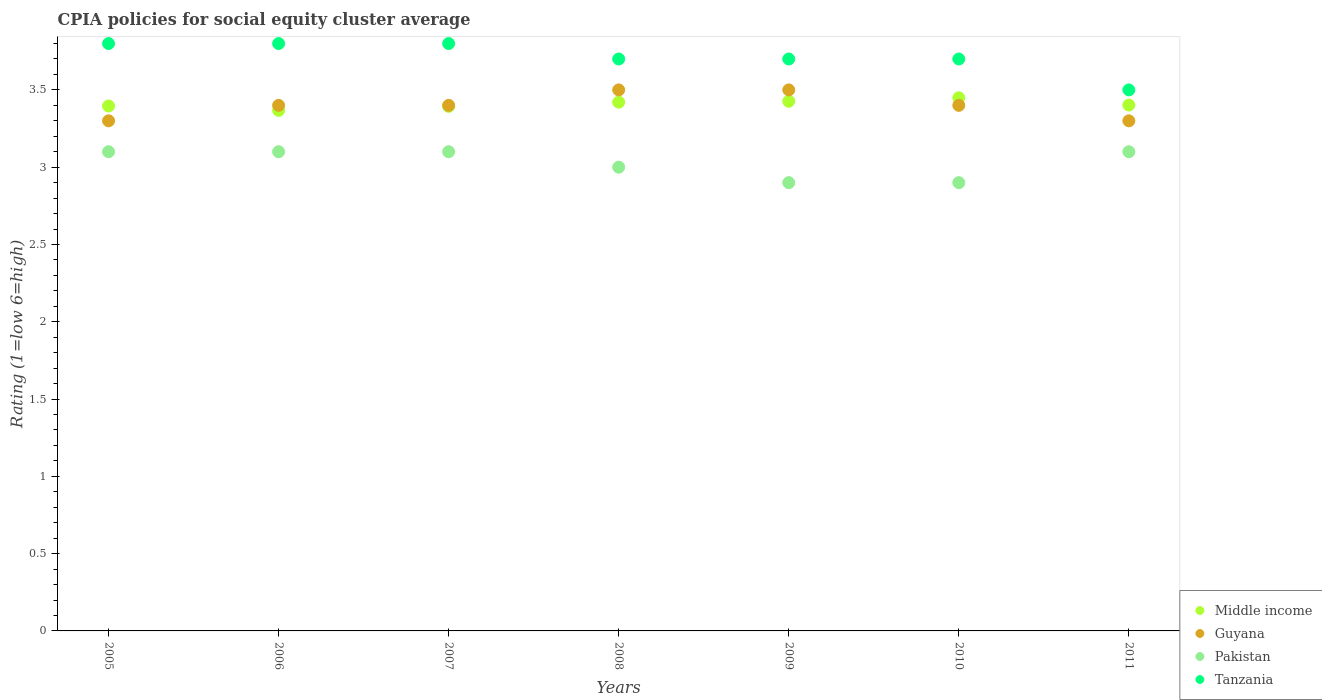Is the number of dotlines equal to the number of legend labels?
Give a very brief answer. Yes. Across all years, what is the maximum CPIA rating in Middle income?
Keep it short and to the point. 3.45. Across all years, what is the minimum CPIA rating in Pakistan?
Give a very brief answer. 2.9. What is the total CPIA rating in Guyana in the graph?
Keep it short and to the point. 23.8. What is the difference between the CPIA rating in Guyana in 2005 and that in 2006?
Offer a very short reply. -0.1. What is the difference between the CPIA rating in Pakistan in 2006 and the CPIA rating in Guyana in 2005?
Keep it short and to the point. -0.2. What is the average CPIA rating in Pakistan per year?
Offer a terse response. 3.03. In the year 2011, what is the difference between the CPIA rating in Guyana and CPIA rating in Tanzania?
Make the answer very short. -0.2. In how many years, is the CPIA rating in Guyana greater than 2.2?
Provide a succinct answer. 7. What is the ratio of the CPIA rating in Tanzania in 2007 to that in 2010?
Your response must be concise. 1.03. Is the difference between the CPIA rating in Guyana in 2006 and 2008 greater than the difference between the CPIA rating in Tanzania in 2006 and 2008?
Your answer should be compact. No. What is the difference between the highest and the lowest CPIA rating in Pakistan?
Your answer should be very brief. 0.2. In how many years, is the CPIA rating in Middle income greater than the average CPIA rating in Middle income taken over all years?
Give a very brief answer. 3. Is it the case that in every year, the sum of the CPIA rating in Pakistan and CPIA rating in Tanzania  is greater than the CPIA rating in Guyana?
Make the answer very short. Yes. Is the CPIA rating in Guyana strictly less than the CPIA rating in Middle income over the years?
Give a very brief answer. No. Are the values on the major ticks of Y-axis written in scientific E-notation?
Offer a very short reply. No. Does the graph contain any zero values?
Your response must be concise. No. How many legend labels are there?
Your answer should be very brief. 4. What is the title of the graph?
Your answer should be compact. CPIA policies for social equity cluster average. What is the label or title of the X-axis?
Make the answer very short. Years. What is the label or title of the Y-axis?
Make the answer very short. Rating (1=low 6=high). What is the Rating (1=low 6=high) of Middle income in 2005?
Ensure brevity in your answer.  3.4. What is the Rating (1=low 6=high) of Pakistan in 2005?
Offer a terse response. 3.1. What is the Rating (1=low 6=high) of Middle income in 2006?
Offer a very short reply. 3.37. What is the Rating (1=low 6=high) of Pakistan in 2006?
Offer a terse response. 3.1. What is the Rating (1=low 6=high) in Middle income in 2007?
Provide a succinct answer. 3.39. What is the Rating (1=low 6=high) of Guyana in 2007?
Your response must be concise. 3.4. What is the Rating (1=low 6=high) of Pakistan in 2007?
Provide a short and direct response. 3.1. What is the Rating (1=low 6=high) in Tanzania in 2007?
Ensure brevity in your answer.  3.8. What is the Rating (1=low 6=high) in Middle income in 2008?
Your answer should be very brief. 3.42. What is the Rating (1=low 6=high) in Middle income in 2009?
Your response must be concise. 3.43. What is the Rating (1=low 6=high) of Guyana in 2009?
Provide a short and direct response. 3.5. What is the Rating (1=low 6=high) in Middle income in 2010?
Your answer should be compact. 3.45. What is the Rating (1=low 6=high) in Pakistan in 2010?
Make the answer very short. 2.9. What is the Rating (1=low 6=high) of Tanzania in 2010?
Offer a very short reply. 3.7. What is the Rating (1=low 6=high) in Middle income in 2011?
Ensure brevity in your answer.  3.4. What is the Rating (1=low 6=high) of Pakistan in 2011?
Make the answer very short. 3.1. What is the Rating (1=low 6=high) of Tanzania in 2011?
Make the answer very short. 3.5. Across all years, what is the maximum Rating (1=low 6=high) in Middle income?
Your response must be concise. 3.45. Across all years, what is the maximum Rating (1=low 6=high) in Pakistan?
Make the answer very short. 3.1. Across all years, what is the maximum Rating (1=low 6=high) of Tanzania?
Provide a succinct answer. 3.8. Across all years, what is the minimum Rating (1=low 6=high) in Middle income?
Your answer should be very brief. 3.37. Across all years, what is the minimum Rating (1=low 6=high) of Tanzania?
Keep it short and to the point. 3.5. What is the total Rating (1=low 6=high) in Middle income in the graph?
Your response must be concise. 23.86. What is the total Rating (1=low 6=high) in Guyana in the graph?
Give a very brief answer. 23.8. What is the total Rating (1=low 6=high) of Pakistan in the graph?
Offer a terse response. 21.2. What is the total Rating (1=low 6=high) in Tanzania in the graph?
Keep it short and to the point. 26. What is the difference between the Rating (1=low 6=high) of Middle income in 2005 and that in 2006?
Your answer should be compact. 0.03. What is the difference between the Rating (1=low 6=high) of Guyana in 2005 and that in 2006?
Your answer should be very brief. -0.1. What is the difference between the Rating (1=low 6=high) in Middle income in 2005 and that in 2007?
Your answer should be compact. 0. What is the difference between the Rating (1=low 6=high) in Tanzania in 2005 and that in 2007?
Ensure brevity in your answer.  0. What is the difference between the Rating (1=low 6=high) of Middle income in 2005 and that in 2008?
Provide a short and direct response. -0.03. What is the difference between the Rating (1=low 6=high) in Guyana in 2005 and that in 2008?
Make the answer very short. -0.2. What is the difference between the Rating (1=low 6=high) in Tanzania in 2005 and that in 2008?
Offer a terse response. 0.1. What is the difference between the Rating (1=low 6=high) in Middle income in 2005 and that in 2009?
Offer a very short reply. -0.03. What is the difference between the Rating (1=low 6=high) in Guyana in 2005 and that in 2009?
Keep it short and to the point. -0.2. What is the difference between the Rating (1=low 6=high) in Tanzania in 2005 and that in 2009?
Your response must be concise. 0.1. What is the difference between the Rating (1=low 6=high) in Middle income in 2005 and that in 2010?
Offer a very short reply. -0.05. What is the difference between the Rating (1=low 6=high) in Guyana in 2005 and that in 2010?
Give a very brief answer. -0.1. What is the difference between the Rating (1=low 6=high) in Middle income in 2005 and that in 2011?
Provide a short and direct response. -0.01. What is the difference between the Rating (1=low 6=high) of Pakistan in 2005 and that in 2011?
Offer a terse response. 0. What is the difference between the Rating (1=low 6=high) in Tanzania in 2005 and that in 2011?
Your answer should be compact. 0.3. What is the difference between the Rating (1=low 6=high) in Middle income in 2006 and that in 2007?
Offer a terse response. -0.03. What is the difference between the Rating (1=low 6=high) in Tanzania in 2006 and that in 2007?
Make the answer very short. 0. What is the difference between the Rating (1=low 6=high) of Middle income in 2006 and that in 2008?
Your answer should be compact. -0.05. What is the difference between the Rating (1=low 6=high) of Pakistan in 2006 and that in 2008?
Your answer should be very brief. 0.1. What is the difference between the Rating (1=low 6=high) of Middle income in 2006 and that in 2009?
Ensure brevity in your answer.  -0.06. What is the difference between the Rating (1=low 6=high) in Tanzania in 2006 and that in 2009?
Provide a short and direct response. 0.1. What is the difference between the Rating (1=low 6=high) in Middle income in 2006 and that in 2010?
Make the answer very short. -0.08. What is the difference between the Rating (1=low 6=high) of Guyana in 2006 and that in 2010?
Your answer should be compact. 0. What is the difference between the Rating (1=low 6=high) in Pakistan in 2006 and that in 2010?
Offer a very short reply. 0.2. What is the difference between the Rating (1=low 6=high) of Middle income in 2006 and that in 2011?
Offer a terse response. -0.03. What is the difference between the Rating (1=low 6=high) in Middle income in 2007 and that in 2008?
Give a very brief answer. -0.03. What is the difference between the Rating (1=low 6=high) of Tanzania in 2007 and that in 2008?
Ensure brevity in your answer.  0.1. What is the difference between the Rating (1=low 6=high) in Middle income in 2007 and that in 2009?
Offer a very short reply. -0.03. What is the difference between the Rating (1=low 6=high) of Pakistan in 2007 and that in 2009?
Your answer should be very brief. 0.2. What is the difference between the Rating (1=low 6=high) in Tanzania in 2007 and that in 2009?
Provide a succinct answer. 0.1. What is the difference between the Rating (1=low 6=high) in Middle income in 2007 and that in 2010?
Provide a short and direct response. -0.06. What is the difference between the Rating (1=low 6=high) of Middle income in 2007 and that in 2011?
Provide a succinct answer. -0.01. What is the difference between the Rating (1=low 6=high) in Guyana in 2007 and that in 2011?
Keep it short and to the point. 0.1. What is the difference between the Rating (1=low 6=high) of Middle income in 2008 and that in 2009?
Make the answer very short. -0.01. What is the difference between the Rating (1=low 6=high) of Guyana in 2008 and that in 2009?
Your answer should be very brief. 0. What is the difference between the Rating (1=low 6=high) of Pakistan in 2008 and that in 2009?
Give a very brief answer. 0.1. What is the difference between the Rating (1=low 6=high) in Middle income in 2008 and that in 2010?
Provide a short and direct response. -0.03. What is the difference between the Rating (1=low 6=high) in Middle income in 2008 and that in 2011?
Provide a succinct answer. 0.02. What is the difference between the Rating (1=low 6=high) in Guyana in 2008 and that in 2011?
Offer a very short reply. 0.2. What is the difference between the Rating (1=low 6=high) of Middle income in 2009 and that in 2010?
Provide a succinct answer. -0.02. What is the difference between the Rating (1=low 6=high) of Middle income in 2009 and that in 2011?
Give a very brief answer. 0.02. What is the difference between the Rating (1=low 6=high) in Guyana in 2009 and that in 2011?
Give a very brief answer. 0.2. What is the difference between the Rating (1=low 6=high) in Tanzania in 2009 and that in 2011?
Keep it short and to the point. 0.2. What is the difference between the Rating (1=low 6=high) of Middle income in 2010 and that in 2011?
Offer a terse response. 0.05. What is the difference between the Rating (1=low 6=high) in Guyana in 2010 and that in 2011?
Keep it short and to the point. 0.1. What is the difference between the Rating (1=low 6=high) of Middle income in 2005 and the Rating (1=low 6=high) of Guyana in 2006?
Offer a terse response. -0. What is the difference between the Rating (1=low 6=high) of Middle income in 2005 and the Rating (1=low 6=high) of Pakistan in 2006?
Your answer should be compact. 0.3. What is the difference between the Rating (1=low 6=high) of Middle income in 2005 and the Rating (1=low 6=high) of Tanzania in 2006?
Keep it short and to the point. -0.4. What is the difference between the Rating (1=low 6=high) of Guyana in 2005 and the Rating (1=low 6=high) of Pakistan in 2006?
Keep it short and to the point. 0.2. What is the difference between the Rating (1=low 6=high) of Middle income in 2005 and the Rating (1=low 6=high) of Guyana in 2007?
Offer a very short reply. -0. What is the difference between the Rating (1=low 6=high) of Middle income in 2005 and the Rating (1=low 6=high) of Pakistan in 2007?
Provide a short and direct response. 0.3. What is the difference between the Rating (1=low 6=high) in Middle income in 2005 and the Rating (1=low 6=high) in Tanzania in 2007?
Provide a succinct answer. -0.4. What is the difference between the Rating (1=low 6=high) in Guyana in 2005 and the Rating (1=low 6=high) in Pakistan in 2007?
Offer a very short reply. 0.2. What is the difference between the Rating (1=low 6=high) of Pakistan in 2005 and the Rating (1=low 6=high) of Tanzania in 2007?
Offer a very short reply. -0.7. What is the difference between the Rating (1=low 6=high) in Middle income in 2005 and the Rating (1=low 6=high) in Guyana in 2008?
Make the answer very short. -0.1. What is the difference between the Rating (1=low 6=high) in Middle income in 2005 and the Rating (1=low 6=high) in Pakistan in 2008?
Ensure brevity in your answer.  0.4. What is the difference between the Rating (1=low 6=high) in Middle income in 2005 and the Rating (1=low 6=high) in Tanzania in 2008?
Ensure brevity in your answer.  -0.3. What is the difference between the Rating (1=low 6=high) in Middle income in 2005 and the Rating (1=low 6=high) in Guyana in 2009?
Provide a succinct answer. -0.1. What is the difference between the Rating (1=low 6=high) of Middle income in 2005 and the Rating (1=low 6=high) of Pakistan in 2009?
Provide a short and direct response. 0.5. What is the difference between the Rating (1=low 6=high) of Middle income in 2005 and the Rating (1=low 6=high) of Tanzania in 2009?
Your answer should be very brief. -0.3. What is the difference between the Rating (1=low 6=high) in Guyana in 2005 and the Rating (1=low 6=high) in Tanzania in 2009?
Provide a succinct answer. -0.4. What is the difference between the Rating (1=low 6=high) of Pakistan in 2005 and the Rating (1=low 6=high) of Tanzania in 2009?
Ensure brevity in your answer.  -0.6. What is the difference between the Rating (1=low 6=high) in Middle income in 2005 and the Rating (1=low 6=high) in Guyana in 2010?
Offer a very short reply. -0. What is the difference between the Rating (1=low 6=high) in Middle income in 2005 and the Rating (1=low 6=high) in Pakistan in 2010?
Ensure brevity in your answer.  0.5. What is the difference between the Rating (1=low 6=high) in Middle income in 2005 and the Rating (1=low 6=high) in Tanzania in 2010?
Provide a short and direct response. -0.3. What is the difference between the Rating (1=low 6=high) in Guyana in 2005 and the Rating (1=low 6=high) in Pakistan in 2010?
Give a very brief answer. 0.4. What is the difference between the Rating (1=low 6=high) of Guyana in 2005 and the Rating (1=low 6=high) of Tanzania in 2010?
Provide a short and direct response. -0.4. What is the difference between the Rating (1=low 6=high) in Pakistan in 2005 and the Rating (1=low 6=high) in Tanzania in 2010?
Your answer should be compact. -0.6. What is the difference between the Rating (1=low 6=high) in Middle income in 2005 and the Rating (1=low 6=high) in Guyana in 2011?
Give a very brief answer. 0.1. What is the difference between the Rating (1=low 6=high) of Middle income in 2005 and the Rating (1=low 6=high) of Pakistan in 2011?
Offer a very short reply. 0.3. What is the difference between the Rating (1=low 6=high) in Middle income in 2005 and the Rating (1=low 6=high) in Tanzania in 2011?
Give a very brief answer. -0.1. What is the difference between the Rating (1=low 6=high) of Guyana in 2005 and the Rating (1=low 6=high) of Tanzania in 2011?
Your answer should be very brief. -0.2. What is the difference between the Rating (1=low 6=high) in Middle income in 2006 and the Rating (1=low 6=high) in Guyana in 2007?
Your response must be concise. -0.03. What is the difference between the Rating (1=low 6=high) in Middle income in 2006 and the Rating (1=low 6=high) in Pakistan in 2007?
Make the answer very short. 0.27. What is the difference between the Rating (1=low 6=high) of Middle income in 2006 and the Rating (1=low 6=high) of Tanzania in 2007?
Make the answer very short. -0.43. What is the difference between the Rating (1=low 6=high) in Guyana in 2006 and the Rating (1=low 6=high) in Pakistan in 2007?
Give a very brief answer. 0.3. What is the difference between the Rating (1=low 6=high) in Middle income in 2006 and the Rating (1=low 6=high) in Guyana in 2008?
Give a very brief answer. -0.13. What is the difference between the Rating (1=low 6=high) of Middle income in 2006 and the Rating (1=low 6=high) of Pakistan in 2008?
Provide a succinct answer. 0.37. What is the difference between the Rating (1=low 6=high) in Middle income in 2006 and the Rating (1=low 6=high) in Tanzania in 2008?
Your answer should be compact. -0.33. What is the difference between the Rating (1=low 6=high) of Guyana in 2006 and the Rating (1=low 6=high) of Pakistan in 2008?
Your response must be concise. 0.4. What is the difference between the Rating (1=low 6=high) in Pakistan in 2006 and the Rating (1=low 6=high) in Tanzania in 2008?
Offer a terse response. -0.6. What is the difference between the Rating (1=low 6=high) of Middle income in 2006 and the Rating (1=low 6=high) of Guyana in 2009?
Your answer should be very brief. -0.13. What is the difference between the Rating (1=low 6=high) of Middle income in 2006 and the Rating (1=low 6=high) of Pakistan in 2009?
Your response must be concise. 0.47. What is the difference between the Rating (1=low 6=high) of Middle income in 2006 and the Rating (1=low 6=high) of Tanzania in 2009?
Provide a succinct answer. -0.33. What is the difference between the Rating (1=low 6=high) in Guyana in 2006 and the Rating (1=low 6=high) in Pakistan in 2009?
Keep it short and to the point. 0.5. What is the difference between the Rating (1=low 6=high) in Pakistan in 2006 and the Rating (1=low 6=high) in Tanzania in 2009?
Keep it short and to the point. -0.6. What is the difference between the Rating (1=low 6=high) in Middle income in 2006 and the Rating (1=low 6=high) in Guyana in 2010?
Make the answer very short. -0.03. What is the difference between the Rating (1=low 6=high) in Middle income in 2006 and the Rating (1=low 6=high) in Pakistan in 2010?
Your answer should be very brief. 0.47. What is the difference between the Rating (1=low 6=high) of Middle income in 2006 and the Rating (1=low 6=high) of Tanzania in 2010?
Your answer should be compact. -0.33. What is the difference between the Rating (1=low 6=high) in Guyana in 2006 and the Rating (1=low 6=high) in Pakistan in 2010?
Ensure brevity in your answer.  0.5. What is the difference between the Rating (1=low 6=high) in Pakistan in 2006 and the Rating (1=low 6=high) in Tanzania in 2010?
Your answer should be compact. -0.6. What is the difference between the Rating (1=low 6=high) in Middle income in 2006 and the Rating (1=low 6=high) in Guyana in 2011?
Your answer should be very brief. 0.07. What is the difference between the Rating (1=low 6=high) of Middle income in 2006 and the Rating (1=low 6=high) of Pakistan in 2011?
Provide a short and direct response. 0.27. What is the difference between the Rating (1=low 6=high) of Middle income in 2006 and the Rating (1=low 6=high) of Tanzania in 2011?
Offer a terse response. -0.13. What is the difference between the Rating (1=low 6=high) of Guyana in 2006 and the Rating (1=low 6=high) of Pakistan in 2011?
Provide a short and direct response. 0.3. What is the difference between the Rating (1=low 6=high) in Pakistan in 2006 and the Rating (1=low 6=high) in Tanzania in 2011?
Make the answer very short. -0.4. What is the difference between the Rating (1=low 6=high) of Middle income in 2007 and the Rating (1=low 6=high) of Guyana in 2008?
Make the answer very short. -0.11. What is the difference between the Rating (1=low 6=high) in Middle income in 2007 and the Rating (1=low 6=high) in Pakistan in 2008?
Provide a succinct answer. 0.39. What is the difference between the Rating (1=low 6=high) in Middle income in 2007 and the Rating (1=low 6=high) in Tanzania in 2008?
Offer a terse response. -0.31. What is the difference between the Rating (1=low 6=high) in Middle income in 2007 and the Rating (1=low 6=high) in Guyana in 2009?
Offer a very short reply. -0.11. What is the difference between the Rating (1=low 6=high) of Middle income in 2007 and the Rating (1=low 6=high) of Pakistan in 2009?
Give a very brief answer. 0.49. What is the difference between the Rating (1=low 6=high) in Middle income in 2007 and the Rating (1=low 6=high) in Tanzania in 2009?
Give a very brief answer. -0.31. What is the difference between the Rating (1=low 6=high) in Guyana in 2007 and the Rating (1=low 6=high) in Tanzania in 2009?
Your answer should be compact. -0.3. What is the difference between the Rating (1=low 6=high) in Pakistan in 2007 and the Rating (1=low 6=high) in Tanzania in 2009?
Offer a very short reply. -0.6. What is the difference between the Rating (1=low 6=high) in Middle income in 2007 and the Rating (1=low 6=high) in Guyana in 2010?
Your answer should be compact. -0.01. What is the difference between the Rating (1=low 6=high) of Middle income in 2007 and the Rating (1=low 6=high) of Pakistan in 2010?
Offer a terse response. 0.49. What is the difference between the Rating (1=low 6=high) in Middle income in 2007 and the Rating (1=low 6=high) in Tanzania in 2010?
Keep it short and to the point. -0.31. What is the difference between the Rating (1=low 6=high) of Guyana in 2007 and the Rating (1=low 6=high) of Pakistan in 2010?
Offer a terse response. 0.5. What is the difference between the Rating (1=low 6=high) in Guyana in 2007 and the Rating (1=low 6=high) in Tanzania in 2010?
Offer a very short reply. -0.3. What is the difference between the Rating (1=low 6=high) of Pakistan in 2007 and the Rating (1=low 6=high) of Tanzania in 2010?
Your answer should be very brief. -0.6. What is the difference between the Rating (1=low 6=high) in Middle income in 2007 and the Rating (1=low 6=high) in Guyana in 2011?
Ensure brevity in your answer.  0.09. What is the difference between the Rating (1=low 6=high) in Middle income in 2007 and the Rating (1=low 6=high) in Pakistan in 2011?
Offer a very short reply. 0.29. What is the difference between the Rating (1=low 6=high) in Middle income in 2007 and the Rating (1=low 6=high) in Tanzania in 2011?
Offer a very short reply. -0.11. What is the difference between the Rating (1=low 6=high) in Guyana in 2007 and the Rating (1=low 6=high) in Tanzania in 2011?
Your response must be concise. -0.1. What is the difference between the Rating (1=low 6=high) in Middle income in 2008 and the Rating (1=low 6=high) in Guyana in 2009?
Your answer should be very brief. -0.08. What is the difference between the Rating (1=low 6=high) in Middle income in 2008 and the Rating (1=low 6=high) in Pakistan in 2009?
Provide a succinct answer. 0.52. What is the difference between the Rating (1=low 6=high) in Middle income in 2008 and the Rating (1=low 6=high) in Tanzania in 2009?
Offer a terse response. -0.28. What is the difference between the Rating (1=low 6=high) of Middle income in 2008 and the Rating (1=low 6=high) of Guyana in 2010?
Offer a very short reply. 0.02. What is the difference between the Rating (1=low 6=high) of Middle income in 2008 and the Rating (1=low 6=high) of Pakistan in 2010?
Offer a terse response. 0.52. What is the difference between the Rating (1=low 6=high) of Middle income in 2008 and the Rating (1=low 6=high) of Tanzania in 2010?
Offer a terse response. -0.28. What is the difference between the Rating (1=low 6=high) of Middle income in 2008 and the Rating (1=low 6=high) of Guyana in 2011?
Ensure brevity in your answer.  0.12. What is the difference between the Rating (1=low 6=high) in Middle income in 2008 and the Rating (1=low 6=high) in Pakistan in 2011?
Your answer should be compact. 0.32. What is the difference between the Rating (1=low 6=high) of Middle income in 2008 and the Rating (1=low 6=high) of Tanzania in 2011?
Provide a short and direct response. -0.08. What is the difference between the Rating (1=low 6=high) of Middle income in 2009 and the Rating (1=low 6=high) of Guyana in 2010?
Your answer should be very brief. 0.03. What is the difference between the Rating (1=low 6=high) of Middle income in 2009 and the Rating (1=low 6=high) of Pakistan in 2010?
Give a very brief answer. 0.53. What is the difference between the Rating (1=low 6=high) in Middle income in 2009 and the Rating (1=low 6=high) in Tanzania in 2010?
Ensure brevity in your answer.  -0.27. What is the difference between the Rating (1=low 6=high) of Guyana in 2009 and the Rating (1=low 6=high) of Pakistan in 2010?
Your answer should be very brief. 0.6. What is the difference between the Rating (1=low 6=high) in Guyana in 2009 and the Rating (1=low 6=high) in Tanzania in 2010?
Offer a very short reply. -0.2. What is the difference between the Rating (1=low 6=high) of Middle income in 2009 and the Rating (1=low 6=high) of Guyana in 2011?
Offer a terse response. 0.13. What is the difference between the Rating (1=low 6=high) in Middle income in 2009 and the Rating (1=low 6=high) in Pakistan in 2011?
Your answer should be compact. 0.33. What is the difference between the Rating (1=low 6=high) in Middle income in 2009 and the Rating (1=low 6=high) in Tanzania in 2011?
Your answer should be compact. -0.07. What is the difference between the Rating (1=low 6=high) of Guyana in 2009 and the Rating (1=low 6=high) of Pakistan in 2011?
Your answer should be compact. 0.4. What is the difference between the Rating (1=low 6=high) in Pakistan in 2009 and the Rating (1=low 6=high) in Tanzania in 2011?
Offer a terse response. -0.6. What is the difference between the Rating (1=low 6=high) of Middle income in 2010 and the Rating (1=low 6=high) of Guyana in 2011?
Give a very brief answer. 0.15. What is the difference between the Rating (1=low 6=high) in Middle income in 2010 and the Rating (1=low 6=high) in Pakistan in 2011?
Your response must be concise. 0.35. What is the difference between the Rating (1=low 6=high) of Middle income in 2010 and the Rating (1=low 6=high) of Tanzania in 2011?
Make the answer very short. -0.05. What is the difference between the Rating (1=low 6=high) of Guyana in 2010 and the Rating (1=low 6=high) of Pakistan in 2011?
Make the answer very short. 0.3. What is the difference between the Rating (1=low 6=high) of Guyana in 2010 and the Rating (1=low 6=high) of Tanzania in 2011?
Make the answer very short. -0.1. What is the difference between the Rating (1=low 6=high) in Pakistan in 2010 and the Rating (1=low 6=high) in Tanzania in 2011?
Your response must be concise. -0.6. What is the average Rating (1=low 6=high) in Middle income per year?
Offer a terse response. 3.41. What is the average Rating (1=low 6=high) in Pakistan per year?
Give a very brief answer. 3.03. What is the average Rating (1=low 6=high) in Tanzania per year?
Ensure brevity in your answer.  3.71. In the year 2005, what is the difference between the Rating (1=low 6=high) of Middle income and Rating (1=low 6=high) of Guyana?
Keep it short and to the point. 0.1. In the year 2005, what is the difference between the Rating (1=low 6=high) of Middle income and Rating (1=low 6=high) of Pakistan?
Provide a succinct answer. 0.3. In the year 2005, what is the difference between the Rating (1=low 6=high) of Middle income and Rating (1=low 6=high) of Tanzania?
Make the answer very short. -0.4. In the year 2005, what is the difference between the Rating (1=low 6=high) in Guyana and Rating (1=low 6=high) in Pakistan?
Your response must be concise. 0.2. In the year 2005, what is the difference between the Rating (1=low 6=high) in Pakistan and Rating (1=low 6=high) in Tanzania?
Make the answer very short. -0.7. In the year 2006, what is the difference between the Rating (1=low 6=high) in Middle income and Rating (1=low 6=high) in Guyana?
Offer a terse response. -0.03. In the year 2006, what is the difference between the Rating (1=low 6=high) of Middle income and Rating (1=low 6=high) of Pakistan?
Make the answer very short. 0.27. In the year 2006, what is the difference between the Rating (1=low 6=high) in Middle income and Rating (1=low 6=high) in Tanzania?
Your answer should be compact. -0.43. In the year 2007, what is the difference between the Rating (1=low 6=high) of Middle income and Rating (1=low 6=high) of Guyana?
Your response must be concise. -0.01. In the year 2007, what is the difference between the Rating (1=low 6=high) in Middle income and Rating (1=low 6=high) in Pakistan?
Keep it short and to the point. 0.29. In the year 2007, what is the difference between the Rating (1=low 6=high) of Middle income and Rating (1=low 6=high) of Tanzania?
Ensure brevity in your answer.  -0.41. In the year 2007, what is the difference between the Rating (1=low 6=high) of Guyana and Rating (1=low 6=high) of Pakistan?
Provide a succinct answer. 0.3. In the year 2007, what is the difference between the Rating (1=low 6=high) in Guyana and Rating (1=low 6=high) in Tanzania?
Keep it short and to the point. -0.4. In the year 2008, what is the difference between the Rating (1=low 6=high) of Middle income and Rating (1=low 6=high) of Guyana?
Your response must be concise. -0.08. In the year 2008, what is the difference between the Rating (1=low 6=high) in Middle income and Rating (1=low 6=high) in Pakistan?
Your answer should be compact. 0.42. In the year 2008, what is the difference between the Rating (1=low 6=high) of Middle income and Rating (1=low 6=high) of Tanzania?
Keep it short and to the point. -0.28. In the year 2008, what is the difference between the Rating (1=low 6=high) of Guyana and Rating (1=low 6=high) of Pakistan?
Your response must be concise. 0.5. In the year 2009, what is the difference between the Rating (1=low 6=high) of Middle income and Rating (1=low 6=high) of Guyana?
Provide a succinct answer. -0.07. In the year 2009, what is the difference between the Rating (1=low 6=high) in Middle income and Rating (1=low 6=high) in Pakistan?
Keep it short and to the point. 0.53. In the year 2009, what is the difference between the Rating (1=low 6=high) of Middle income and Rating (1=low 6=high) of Tanzania?
Your answer should be very brief. -0.27. In the year 2009, what is the difference between the Rating (1=low 6=high) in Guyana and Rating (1=low 6=high) in Pakistan?
Your answer should be very brief. 0.6. In the year 2009, what is the difference between the Rating (1=low 6=high) in Guyana and Rating (1=low 6=high) in Tanzania?
Offer a terse response. -0.2. In the year 2010, what is the difference between the Rating (1=low 6=high) in Middle income and Rating (1=low 6=high) in Guyana?
Your response must be concise. 0.05. In the year 2010, what is the difference between the Rating (1=low 6=high) in Middle income and Rating (1=low 6=high) in Pakistan?
Give a very brief answer. 0.55. In the year 2010, what is the difference between the Rating (1=low 6=high) of Middle income and Rating (1=low 6=high) of Tanzania?
Your answer should be very brief. -0.25. In the year 2010, what is the difference between the Rating (1=low 6=high) of Guyana and Rating (1=low 6=high) of Tanzania?
Provide a short and direct response. -0.3. In the year 2010, what is the difference between the Rating (1=low 6=high) in Pakistan and Rating (1=low 6=high) in Tanzania?
Provide a short and direct response. -0.8. In the year 2011, what is the difference between the Rating (1=low 6=high) of Middle income and Rating (1=low 6=high) of Guyana?
Your response must be concise. 0.1. In the year 2011, what is the difference between the Rating (1=low 6=high) of Middle income and Rating (1=low 6=high) of Pakistan?
Your answer should be very brief. 0.3. In the year 2011, what is the difference between the Rating (1=low 6=high) of Middle income and Rating (1=low 6=high) of Tanzania?
Give a very brief answer. -0.1. In the year 2011, what is the difference between the Rating (1=low 6=high) of Guyana and Rating (1=low 6=high) of Pakistan?
Offer a very short reply. 0.2. In the year 2011, what is the difference between the Rating (1=low 6=high) of Pakistan and Rating (1=low 6=high) of Tanzania?
Your answer should be compact. -0.4. What is the ratio of the Rating (1=low 6=high) of Middle income in 2005 to that in 2006?
Make the answer very short. 1.01. What is the ratio of the Rating (1=low 6=high) in Guyana in 2005 to that in 2006?
Keep it short and to the point. 0.97. What is the ratio of the Rating (1=low 6=high) in Pakistan in 2005 to that in 2006?
Offer a very short reply. 1. What is the ratio of the Rating (1=low 6=high) of Guyana in 2005 to that in 2007?
Offer a very short reply. 0.97. What is the ratio of the Rating (1=low 6=high) of Guyana in 2005 to that in 2008?
Offer a very short reply. 0.94. What is the ratio of the Rating (1=low 6=high) of Guyana in 2005 to that in 2009?
Your answer should be very brief. 0.94. What is the ratio of the Rating (1=low 6=high) of Pakistan in 2005 to that in 2009?
Your answer should be very brief. 1.07. What is the ratio of the Rating (1=low 6=high) of Tanzania in 2005 to that in 2009?
Your answer should be very brief. 1.03. What is the ratio of the Rating (1=low 6=high) in Middle income in 2005 to that in 2010?
Give a very brief answer. 0.98. What is the ratio of the Rating (1=low 6=high) of Guyana in 2005 to that in 2010?
Your answer should be very brief. 0.97. What is the ratio of the Rating (1=low 6=high) in Pakistan in 2005 to that in 2010?
Give a very brief answer. 1.07. What is the ratio of the Rating (1=low 6=high) in Tanzania in 2005 to that in 2010?
Keep it short and to the point. 1.03. What is the ratio of the Rating (1=low 6=high) in Middle income in 2005 to that in 2011?
Keep it short and to the point. 1. What is the ratio of the Rating (1=low 6=high) in Guyana in 2005 to that in 2011?
Offer a very short reply. 1. What is the ratio of the Rating (1=low 6=high) of Tanzania in 2005 to that in 2011?
Make the answer very short. 1.09. What is the ratio of the Rating (1=low 6=high) of Middle income in 2006 to that in 2007?
Make the answer very short. 0.99. What is the ratio of the Rating (1=low 6=high) of Tanzania in 2006 to that in 2007?
Your response must be concise. 1. What is the ratio of the Rating (1=low 6=high) of Middle income in 2006 to that in 2008?
Ensure brevity in your answer.  0.98. What is the ratio of the Rating (1=low 6=high) in Guyana in 2006 to that in 2008?
Keep it short and to the point. 0.97. What is the ratio of the Rating (1=low 6=high) of Pakistan in 2006 to that in 2008?
Your answer should be compact. 1.03. What is the ratio of the Rating (1=low 6=high) of Middle income in 2006 to that in 2009?
Your answer should be compact. 0.98. What is the ratio of the Rating (1=low 6=high) of Guyana in 2006 to that in 2009?
Give a very brief answer. 0.97. What is the ratio of the Rating (1=low 6=high) of Pakistan in 2006 to that in 2009?
Offer a very short reply. 1.07. What is the ratio of the Rating (1=low 6=high) of Tanzania in 2006 to that in 2009?
Offer a very short reply. 1.03. What is the ratio of the Rating (1=low 6=high) of Middle income in 2006 to that in 2010?
Your response must be concise. 0.98. What is the ratio of the Rating (1=low 6=high) of Guyana in 2006 to that in 2010?
Provide a short and direct response. 1. What is the ratio of the Rating (1=low 6=high) of Pakistan in 2006 to that in 2010?
Your answer should be compact. 1.07. What is the ratio of the Rating (1=low 6=high) in Tanzania in 2006 to that in 2010?
Your answer should be very brief. 1.03. What is the ratio of the Rating (1=low 6=high) in Middle income in 2006 to that in 2011?
Provide a succinct answer. 0.99. What is the ratio of the Rating (1=low 6=high) in Guyana in 2006 to that in 2011?
Make the answer very short. 1.03. What is the ratio of the Rating (1=low 6=high) of Pakistan in 2006 to that in 2011?
Your answer should be very brief. 1. What is the ratio of the Rating (1=low 6=high) in Tanzania in 2006 to that in 2011?
Keep it short and to the point. 1.09. What is the ratio of the Rating (1=low 6=high) of Guyana in 2007 to that in 2008?
Make the answer very short. 0.97. What is the ratio of the Rating (1=low 6=high) in Tanzania in 2007 to that in 2008?
Give a very brief answer. 1.03. What is the ratio of the Rating (1=low 6=high) in Guyana in 2007 to that in 2009?
Give a very brief answer. 0.97. What is the ratio of the Rating (1=low 6=high) of Pakistan in 2007 to that in 2009?
Your answer should be very brief. 1.07. What is the ratio of the Rating (1=low 6=high) in Middle income in 2007 to that in 2010?
Offer a very short reply. 0.98. What is the ratio of the Rating (1=low 6=high) in Pakistan in 2007 to that in 2010?
Provide a short and direct response. 1.07. What is the ratio of the Rating (1=low 6=high) in Tanzania in 2007 to that in 2010?
Offer a very short reply. 1.03. What is the ratio of the Rating (1=low 6=high) in Middle income in 2007 to that in 2011?
Offer a terse response. 1. What is the ratio of the Rating (1=low 6=high) of Guyana in 2007 to that in 2011?
Offer a very short reply. 1.03. What is the ratio of the Rating (1=low 6=high) of Pakistan in 2007 to that in 2011?
Provide a short and direct response. 1. What is the ratio of the Rating (1=low 6=high) in Tanzania in 2007 to that in 2011?
Your answer should be compact. 1.09. What is the ratio of the Rating (1=low 6=high) of Guyana in 2008 to that in 2009?
Provide a succinct answer. 1. What is the ratio of the Rating (1=low 6=high) of Pakistan in 2008 to that in 2009?
Offer a terse response. 1.03. What is the ratio of the Rating (1=low 6=high) of Guyana in 2008 to that in 2010?
Your answer should be very brief. 1.03. What is the ratio of the Rating (1=low 6=high) of Pakistan in 2008 to that in 2010?
Provide a succinct answer. 1.03. What is the ratio of the Rating (1=low 6=high) in Middle income in 2008 to that in 2011?
Offer a very short reply. 1.01. What is the ratio of the Rating (1=low 6=high) of Guyana in 2008 to that in 2011?
Your response must be concise. 1.06. What is the ratio of the Rating (1=low 6=high) of Tanzania in 2008 to that in 2011?
Make the answer very short. 1.06. What is the ratio of the Rating (1=low 6=high) of Guyana in 2009 to that in 2010?
Provide a succinct answer. 1.03. What is the ratio of the Rating (1=low 6=high) of Pakistan in 2009 to that in 2010?
Your response must be concise. 1. What is the ratio of the Rating (1=low 6=high) in Middle income in 2009 to that in 2011?
Make the answer very short. 1.01. What is the ratio of the Rating (1=low 6=high) of Guyana in 2009 to that in 2011?
Ensure brevity in your answer.  1.06. What is the ratio of the Rating (1=low 6=high) of Pakistan in 2009 to that in 2011?
Your answer should be compact. 0.94. What is the ratio of the Rating (1=low 6=high) in Tanzania in 2009 to that in 2011?
Your answer should be very brief. 1.06. What is the ratio of the Rating (1=low 6=high) in Middle income in 2010 to that in 2011?
Provide a succinct answer. 1.01. What is the ratio of the Rating (1=low 6=high) in Guyana in 2010 to that in 2011?
Offer a very short reply. 1.03. What is the ratio of the Rating (1=low 6=high) of Pakistan in 2010 to that in 2011?
Give a very brief answer. 0.94. What is the ratio of the Rating (1=low 6=high) in Tanzania in 2010 to that in 2011?
Your response must be concise. 1.06. What is the difference between the highest and the second highest Rating (1=low 6=high) of Middle income?
Provide a short and direct response. 0.02. What is the difference between the highest and the second highest Rating (1=low 6=high) in Guyana?
Offer a terse response. 0. What is the difference between the highest and the lowest Rating (1=low 6=high) of Middle income?
Offer a terse response. 0.08. What is the difference between the highest and the lowest Rating (1=low 6=high) of Pakistan?
Offer a terse response. 0.2. What is the difference between the highest and the lowest Rating (1=low 6=high) of Tanzania?
Your response must be concise. 0.3. 